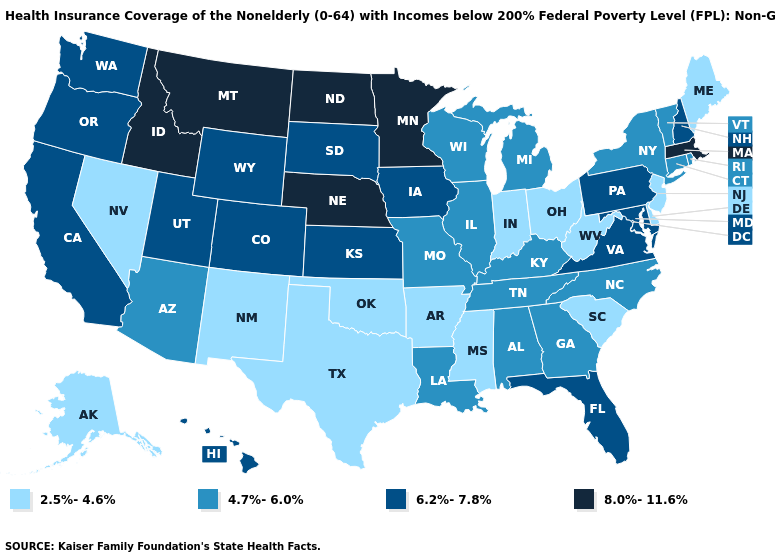What is the value of North Dakota?
Quick response, please. 8.0%-11.6%. What is the value of Connecticut?
Write a very short answer. 4.7%-6.0%. Name the states that have a value in the range 2.5%-4.6%?
Concise answer only. Alaska, Arkansas, Delaware, Indiana, Maine, Mississippi, Nevada, New Jersey, New Mexico, Ohio, Oklahoma, South Carolina, Texas, West Virginia. Does Pennsylvania have the lowest value in the USA?
Quick response, please. No. What is the highest value in the Northeast ?
Concise answer only. 8.0%-11.6%. Does South Dakota have a lower value than Massachusetts?
Concise answer only. Yes. What is the value of Michigan?
Keep it brief. 4.7%-6.0%. Among the states that border Virginia , does Tennessee have the lowest value?
Be succinct. No. Which states hav the highest value in the Northeast?
Concise answer only. Massachusetts. How many symbols are there in the legend?
Short answer required. 4. What is the value of North Carolina?
Short answer required. 4.7%-6.0%. Name the states that have a value in the range 4.7%-6.0%?
Give a very brief answer. Alabama, Arizona, Connecticut, Georgia, Illinois, Kentucky, Louisiana, Michigan, Missouri, New York, North Carolina, Rhode Island, Tennessee, Vermont, Wisconsin. Does Wisconsin have the lowest value in the MidWest?
Give a very brief answer. No. Name the states that have a value in the range 8.0%-11.6%?
Concise answer only. Idaho, Massachusetts, Minnesota, Montana, Nebraska, North Dakota. What is the highest value in the USA?
Be succinct. 8.0%-11.6%. 